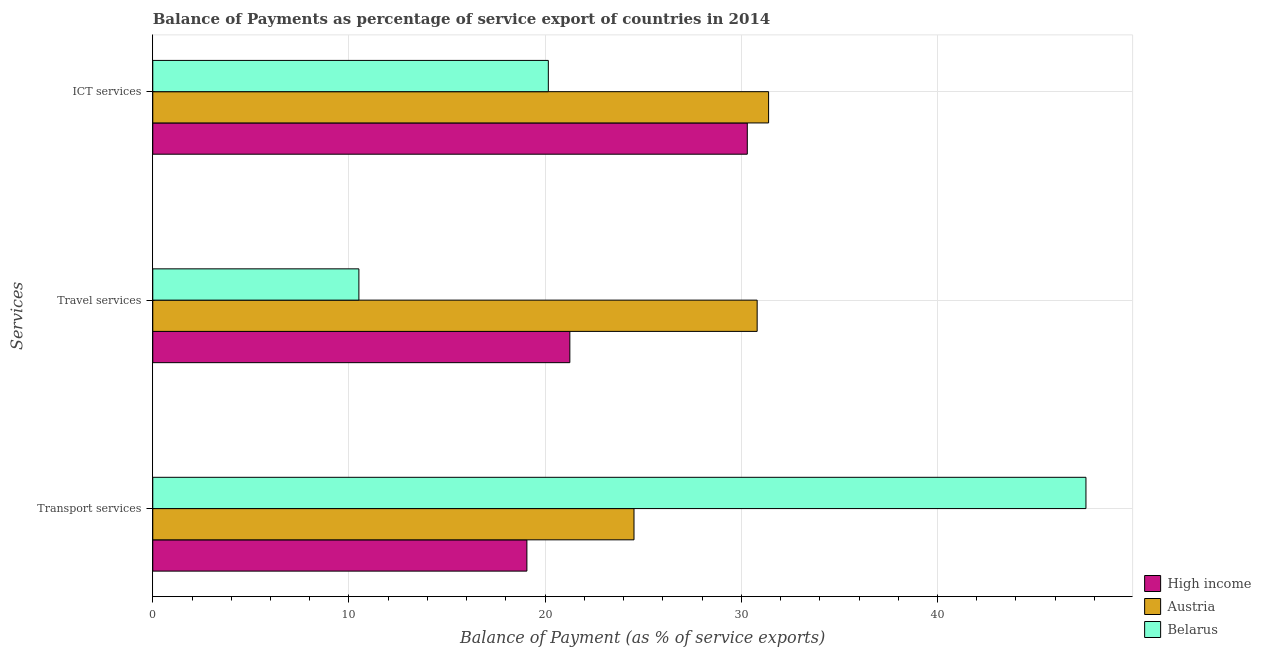How many groups of bars are there?
Give a very brief answer. 3. Are the number of bars per tick equal to the number of legend labels?
Your answer should be very brief. Yes. Are the number of bars on each tick of the Y-axis equal?
Your answer should be very brief. Yes. What is the label of the 2nd group of bars from the top?
Ensure brevity in your answer.  Travel services. What is the balance of payment of transport services in Belarus?
Your answer should be very brief. 47.57. Across all countries, what is the maximum balance of payment of travel services?
Offer a very short reply. 30.81. Across all countries, what is the minimum balance of payment of ict services?
Offer a very short reply. 20.16. In which country was the balance of payment of transport services maximum?
Your answer should be very brief. Belarus. In which country was the balance of payment of travel services minimum?
Your answer should be very brief. Belarus. What is the total balance of payment of transport services in the graph?
Your answer should be very brief. 91.17. What is the difference between the balance of payment of travel services in Austria and that in High income?
Keep it short and to the point. 9.55. What is the difference between the balance of payment of transport services in Austria and the balance of payment of travel services in Belarus?
Give a very brief answer. 14.02. What is the average balance of payment of transport services per country?
Your response must be concise. 30.39. What is the difference between the balance of payment of ict services and balance of payment of transport services in Belarus?
Offer a terse response. -27.4. In how many countries, is the balance of payment of ict services greater than 18 %?
Ensure brevity in your answer.  3. What is the ratio of the balance of payment of travel services in Austria to that in High income?
Provide a succinct answer. 1.45. What is the difference between the highest and the second highest balance of payment of ict services?
Your answer should be very brief. 1.09. What is the difference between the highest and the lowest balance of payment of transport services?
Your response must be concise. 28.5. Is the sum of the balance of payment of ict services in High income and Austria greater than the maximum balance of payment of travel services across all countries?
Your answer should be very brief. Yes. What does the 2nd bar from the bottom in Travel services represents?
Provide a succinct answer. Austria. Is it the case that in every country, the sum of the balance of payment of transport services and balance of payment of travel services is greater than the balance of payment of ict services?
Keep it short and to the point. Yes. Are all the bars in the graph horizontal?
Provide a short and direct response. Yes. How many countries are there in the graph?
Your answer should be very brief. 3. What is the difference between two consecutive major ticks on the X-axis?
Ensure brevity in your answer.  10. Does the graph contain grids?
Keep it short and to the point. Yes. Where does the legend appear in the graph?
Make the answer very short. Bottom right. What is the title of the graph?
Provide a succinct answer. Balance of Payments as percentage of service export of countries in 2014. What is the label or title of the X-axis?
Your answer should be compact. Balance of Payment (as % of service exports). What is the label or title of the Y-axis?
Make the answer very short. Services. What is the Balance of Payment (as % of service exports) in High income in Transport services?
Your answer should be compact. 19.07. What is the Balance of Payment (as % of service exports) in Austria in Transport services?
Ensure brevity in your answer.  24.53. What is the Balance of Payment (as % of service exports) of Belarus in Transport services?
Your response must be concise. 47.57. What is the Balance of Payment (as % of service exports) of High income in Travel services?
Ensure brevity in your answer.  21.26. What is the Balance of Payment (as % of service exports) of Austria in Travel services?
Your answer should be compact. 30.81. What is the Balance of Payment (as % of service exports) of Belarus in Travel services?
Ensure brevity in your answer.  10.51. What is the Balance of Payment (as % of service exports) in High income in ICT services?
Keep it short and to the point. 30.3. What is the Balance of Payment (as % of service exports) in Austria in ICT services?
Your answer should be compact. 31.39. What is the Balance of Payment (as % of service exports) of Belarus in ICT services?
Provide a short and direct response. 20.16. Across all Services, what is the maximum Balance of Payment (as % of service exports) of High income?
Provide a succinct answer. 30.3. Across all Services, what is the maximum Balance of Payment (as % of service exports) of Austria?
Your answer should be compact. 31.39. Across all Services, what is the maximum Balance of Payment (as % of service exports) in Belarus?
Give a very brief answer. 47.57. Across all Services, what is the minimum Balance of Payment (as % of service exports) in High income?
Offer a very short reply. 19.07. Across all Services, what is the minimum Balance of Payment (as % of service exports) of Austria?
Offer a terse response. 24.53. Across all Services, what is the minimum Balance of Payment (as % of service exports) of Belarus?
Provide a succinct answer. 10.51. What is the total Balance of Payment (as % of service exports) in High income in the graph?
Offer a very short reply. 70.63. What is the total Balance of Payment (as % of service exports) in Austria in the graph?
Ensure brevity in your answer.  86.73. What is the total Balance of Payment (as % of service exports) of Belarus in the graph?
Your answer should be very brief. 78.24. What is the difference between the Balance of Payment (as % of service exports) in High income in Transport services and that in Travel services?
Make the answer very short. -2.19. What is the difference between the Balance of Payment (as % of service exports) in Austria in Transport services and that in Travel services?
Make the answer very short. -6.28. What is the difference between the Balance of Payment (as % of service exports) of Belarus in Transport services and that in Travel services?
Your answer should be compact. 37.06. What is the difference between the Balance of Payment (as % of service exports) of High income in Transport services and that in ICT services?
Offer a very short reply. -11.23. What is the difference between the Balance of Payment (as % of service exports) in Austria in Transport services and that in ICT services?
Provide a short and direct response. -6.86. What is the difference between the Balance of Payment (as % of service exports) in Belarus in Transport services and that in ICT services?
Offer a terse response. 27.4. What is the difference between the Balance of Payment (as % of service exports) of High income in Travel services and that in ICT services?
Keep it short and to the point. -9.04. What is the difference between the Balance of Payment (as % of service exports) of Austria in Travel services and that in ICT services?
Provide a short and direct response. -0.58. What is the difference between the Balance of Payment (as % of service exports) of Belarus in Travel services and that in ICT services?
Provide a succinct answer. -9.66. What is the difference between the Balance of Payment (as % of service exports) in High income in Transport services and the Balance of Payment (as % of service exports) in Austria in Travel services?
Keep it short and to the point. -11.74. What is the difference between the Balance of Payment (as % of service exports) of High income in Transport services and the Balance of Payment (as % of service exports) of Belarus in Travel services?
Give a very brief answer. 8.56. What is the difference between the Balance of Payment (as % of service exports) in Austria in Transport services and the Balance of Payment (as % of service exports) in Belarus in Travel services?
Offer a terse response. 14.02. What is the difference between the Balance of Payment (as % of service exports) of High income in Transport services and the Balance of Payment (as % of service exports) of Austria in ICT services?
Ensure brevity in your answer.  -12.32. What is the difference between the Balance of Payment (as % of service exports) in High income in Transport services and the Balance of Payment (as % of service exports) in Belarus in ICT services?
Provide a short and direct response. -1.09. What is the difference between the Balance of Payment (as % of service exports) of Austria in Transport services and the Balance of Payment (as % of service exports) of Belarus in ICT services?
Provide a short and direct response. 4.37. What is the difference between the Balance of Payment (as % of service exports) of High income in Travel services and the Balance of Payment (as % of service exports) of Austria in ICT services?
Your answer should be compact. -10.13. What is the difference between the Balance of Payment (as % of service exports) in High income in Travel services and the Balance of Payment (as % of service exports) in Belarus in ICT services?
Make the answer very short. 1.1. What is the difference between the Balance of Payment (as % of service exports) in Austria in Travel services and the Balance of Payment (as % of service exports) in Belarus in ICT services?
Provide a short and direct response. 10.64. What is the average Balance of Payment (as % of service exports) in High income per Services?
Make the answer very short. 23.54. What is the average Balance of Payment (as % of service exports) of Austria per Services?
Offer a terse response. 28.91. What is the average Balance of Payment (as % of service exports) of Belarus per Services?
Provide a short and direct response. 26.08. What is the difference between the Balance of Payment (as % of service exports) in High income and Balance of Payment (as % of service exports) in Austria in Transport services?
Offer a very short reply. -5.46. What is the difference between the Balance of Payment (as % of service exports) in High income and Balance of Payment (as % of service exports) in Belarus in Transport services?
Your response must be concise. -28.5. What is the difference between the Balance of Payment (as % of service exports) in Austria and Balance of Payment (as % of service exports) in Belarus in Transport services?
Provide a succinct answer. -23.04. What is the difference between the Balance of Payment (as % of service exports) in High income and Balance of Payment (as % of service exports) in Austria in Travel services?
Make the answer very short. -9.55. What is the difference between the Balance of Payment (as % of service exports) of High income and Balance of Payment (as % of service exports) of Belarus in Travel services?
Offer a terse response. 10.75. What is the difference between the Balance of Payment (as % of service exports) in Austria and Balance of Payment (as % of service exports) in Belarus in Travel services?
Ensure brevity in your answer.  20.3. What is the difference between the Balance of Payment (as % of service exports) of High income and Balance of Payment (as % of service exports) of Austria in ICT services?
Give a very brief answer. -1.09. What is the difference between the Balance of Payment (as % of service exports) of High income and Balance of Payment (as % of service exports) of Belarus in ICT services?
Your response must be concise. 10.14. What is the difference between the Balance of Payment (as % of service exports) in Austria and Balance of Payment (as % of service exports) in Belarus in ICT services?
Provide a succinct answer. 11.23. What is the ratio of the Balance of Payment (as % of service exports) in High income in Transport services to that in Travel services?
Keep it short and to the point. 0.9. What is the ratio of the Balance of Payment (as % of service exports) of Austria in Transport services to that in Travel services?
Your answer should be compact. 0.8. What is the ratio of the Balance of Payment (as % of service exports) of Belarus in Transport services to that in Travel services?
Your answer should be very brief. 4.53. What is the ratio of the Balance of Payment (as % of service exports) of High income in Transport services to that in ICT services?
Your answer should be very brief. 0.63. What is the ratio of the Balance of Payment (as % of service exports) of Austria in Transport services to that in ICT services?
Your answer should be very brief. 0.78. What is the ratio of the Balance of Payment (as % of service exports) in Belarus in Transport services to that in ICT services?
Give a very brief answer. 2.36. What is the ratio of the Balance of Payment (as % of service exports) of High income in Travel services to that in ICT services?
Provide a short and direct response. 0.7. What is the ratio of the Balance of Payment (as % of service exports) in Austria in Travel services to that in ICT services?
Your answer should be very brief. 0.98. What is the ratio of the Balance of Payment (as % of service exports) in Belarus in Travel services to that in ICT services?
Your answer should be very brief. 0.52. What is the difference between the highest and the second highest Balance of Payment (as % of service exports) in High income?
Give a very brief answer. 9.04. What is the difference between the highest and the second highest Balance of Payment (as % of service exports) of Austria?
Provide a succinct answer. 0.58. What is the difference between the highest and the second highest Balance of Payment (as % of service exports) in Belarus?
Offer a very short reply. 27.4. What is the difference between the highest and the lowest Balance of Payment (as % of service exports) in High income?
Your answer should be compact. 11.23. What is the difference between the highest and the lowest Balance of Payment (as % of service exports) in Austria?
Offer a very short reply. 6.86. What is the difference between the highest and the lowest Balance of Payment (as % of service exports) in Belarus?
Ensure brevity in your answer.  37.06. 